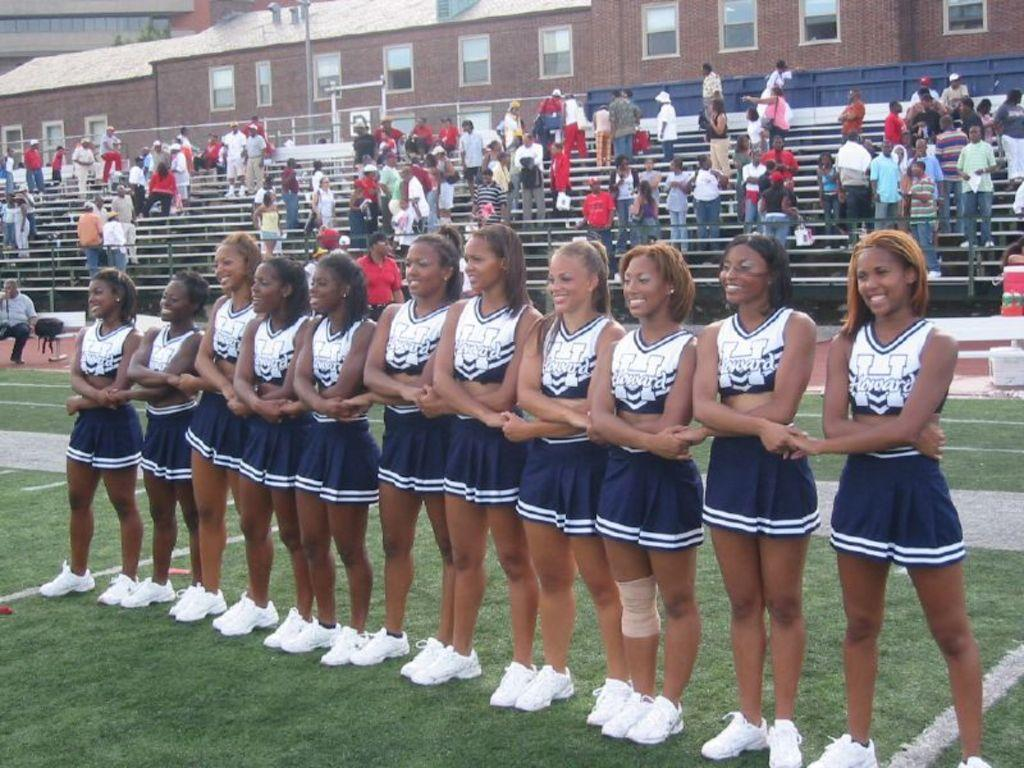What is the main activity of the people in the image? The people in the image are standing on the grass and stairs. Can you describe the location of the people in the image? There are people standing on the grass and on a group of stairs. What can be seen in the background of the image? Buildings are visible in the background of the image. What type of nail is being hammered into the wall in the image? There is no nail being hammered into the wall in the image; the focus is on the people standing on the grass and stairs. 